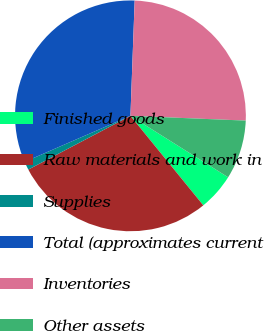Convert chart to OTSL. <chart><loc_0><loc_0><loc_500><loc_500><pie_chart><fcel>Finished goods<fcel>Raw materials and work in<fcel>Supplies<fcel>Total (approximates current<fcel>Inventories<fcel>Other assets<nl><fcel>5.19%<fcel>28.16%<fcel>1.18%<fcel>32.11%<fcel>25.07%<fcel>8.28%<nl></chart> 